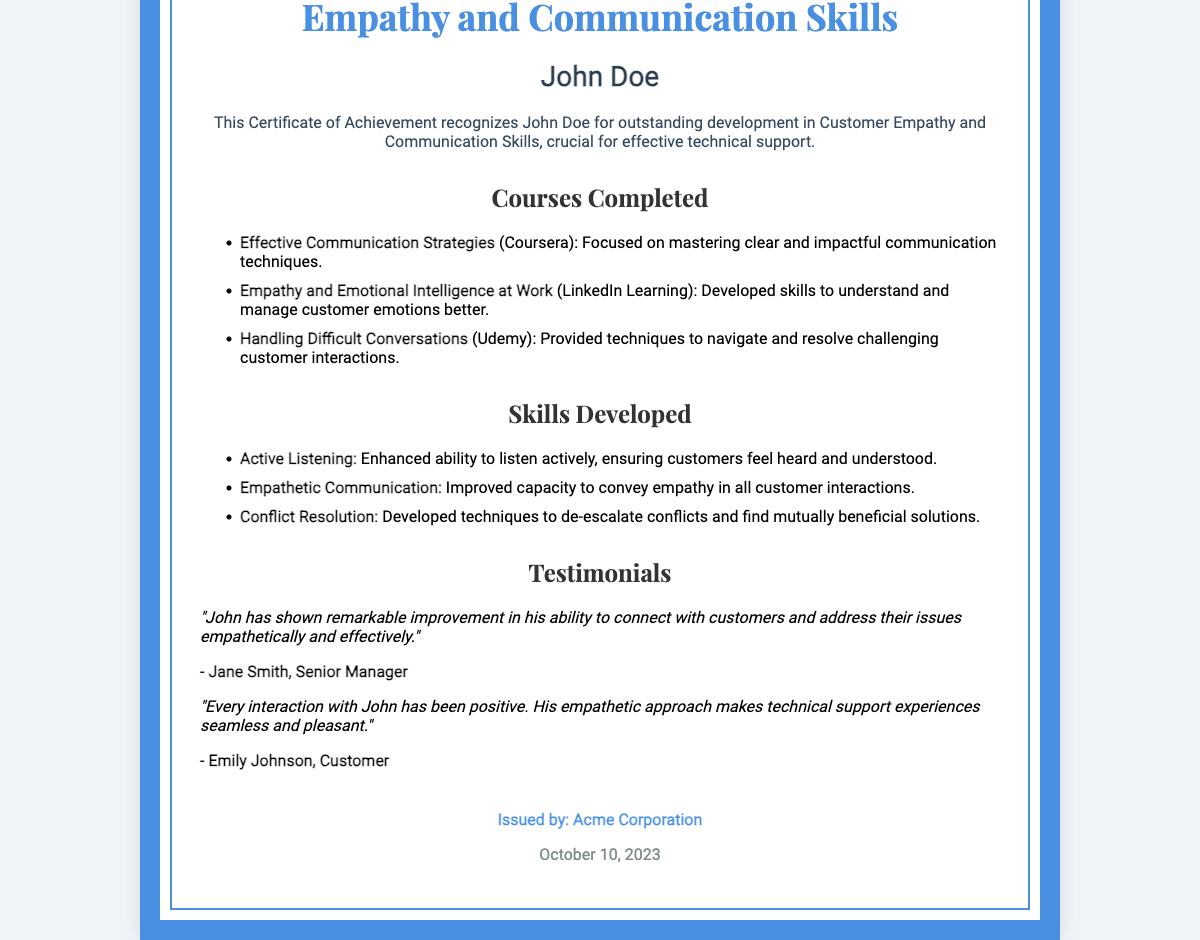What is the title of the certificate? The title of the certificate is mentioned at the top and indicates the area of achievement recognized.
Answer: Certificate of Achievement in Customer Empathy and Communication Skills Who is the recipient of the certificate? The name of the recipient is indicated in the document and highlights who earned the certificate.
Answer: John Doe What is the date of issuance? The date is shown at the bottom of the certificate and indicates when it was issued.
Answer: October 10, 2023 How many courses are listed in the document? The number of courses can be counted based on the list provided under the "Courses Completed" section.
Answer: 3 Which course focuses on mastering communication techniques? The course title explicitly outlines its focus on communication strategies.
Answer: Effective Communication Strategies What skill involves listening actively? The skill is described as enhancing the ability to listen and is listed under "Skills Developed."
Answer: Active Listening Which organization issued the certificate? The issuer's name is provided at the end, indicating who recognized the achievement.
Answer: Acme Corporation How did Jane Smith describe John's improvement? The testimonial provides insight into her perception of John's skills and interactions.
Answer: Remarkable improvement What type of skills does the certificate emphasize? The document highlights skills crucial for a specific professional role, indicating the area of focus.
Answer: Soft skills 